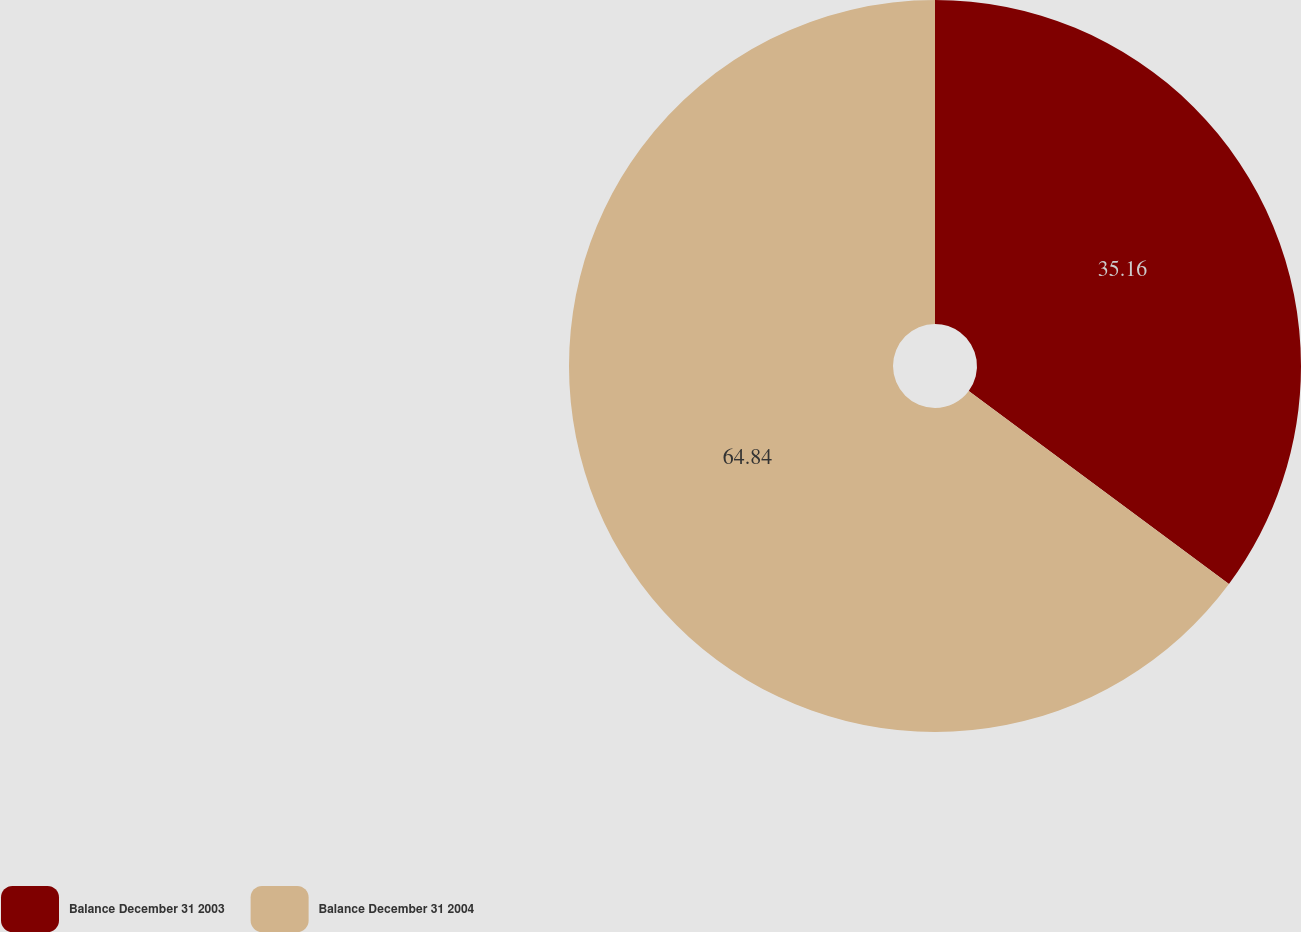Convert chart. <chart><loc_0><loc_0><loc_500><loc_500><pie_chart><fcel>Balance December 31 2003<fcel>Balance December 31 2004<nl><fcel>35.16%<fcel>64.84%<nl></chart> 